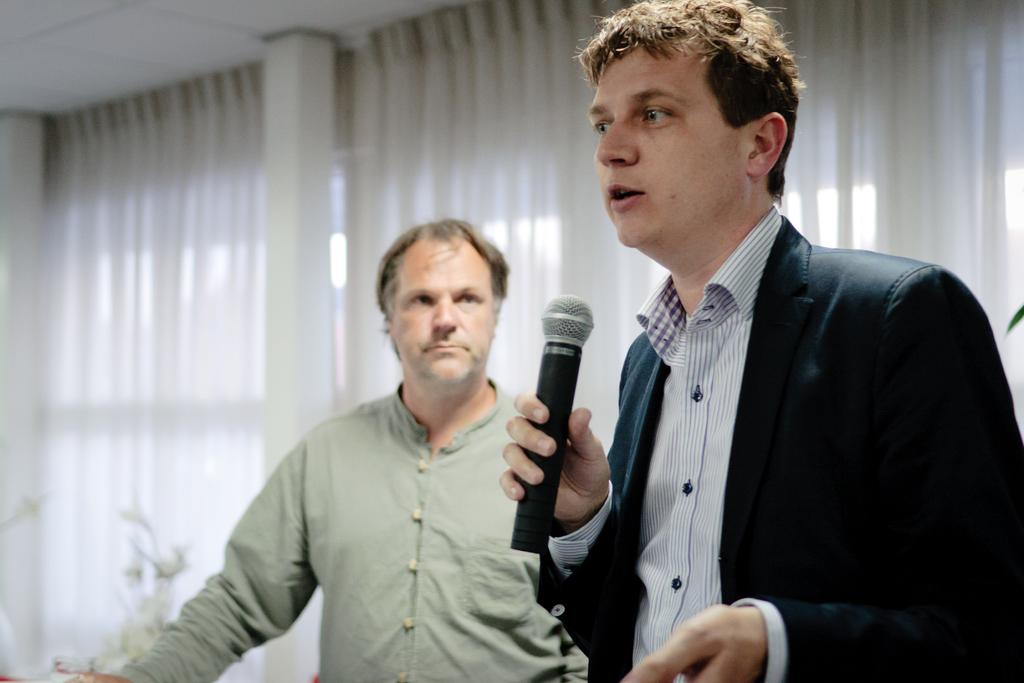What type of window treatment is visible in the image? There are white color curtains in the image. How many people are present in the image? There are two people in the image. Can you describe one of the individuals in the image? One of the people is a man, and he is on the right side of the image. What is the man holding in his hand? The man is holding a mic in his hand. What type of creature can be seen walking on its feet in the image? There is no creature present in the image, and therefore no such activity can be observed. Can you tell me how many bones are visible in the image? There are no bones visible in the image. 